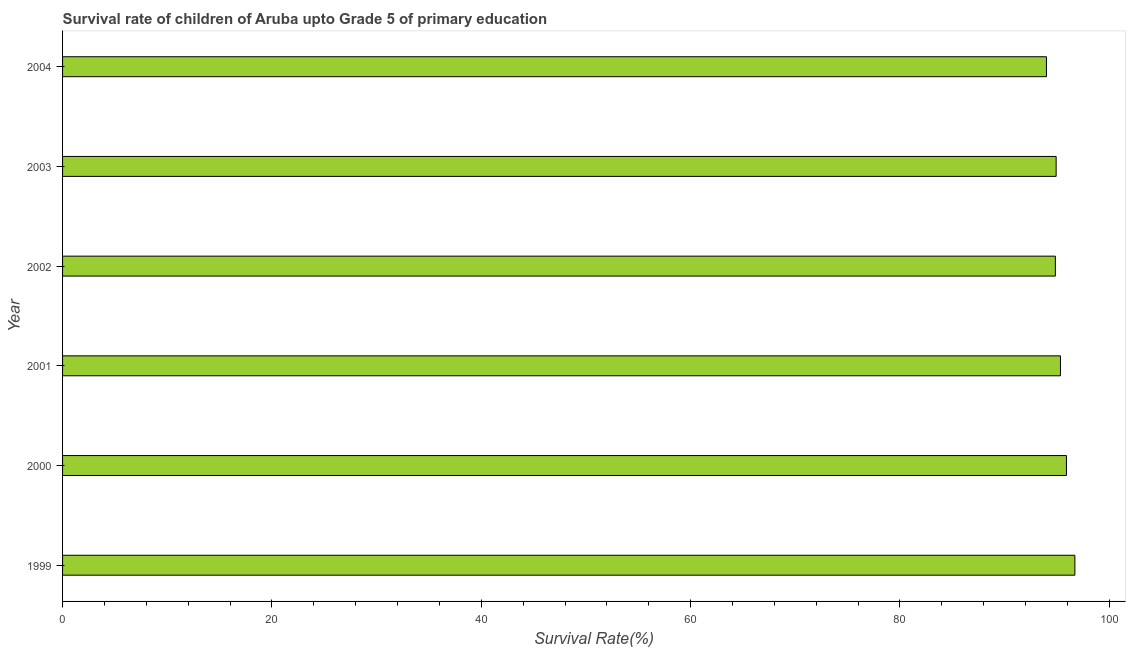Does the graph contain any zero values?
Keep it short and to the point. No. Does the graph contain grids?
Offer a terse response. No. What is the title of the graph?
Your answer should be compact. Survival rate of children of Aruba upto Grade 5 of primary education. What is the label or title of the X-axis?
Offer a terse response. Survival Rate(%). What is the survival rate in 1999?
Offer a terse response. 96.71. Across all years, what is the maximum survival rate?
Offer a terse response. 96.71. Across all years, what is the minimum survival rate?
Keep it short and to the point. 94. In which year was the survival rate maximum?
Your answer should be very brief. 1999. In which year was the survival rate minimum?
Make the answer very short. 2004. What is the sum of the survival rate?
Make the answer very short. 571.71. What is the difference between the survival rate in 1999 and 2002?
Your answer should be compact. 1.86. What is the average survival rate per year?
Keep it short and to the point. 95.28. What is the median survival rate?
Your answer should be very brief. 95.13. Is the difference between the survival rate in 2001 and 2002 greater than the difference between any two years?
Offer a very short reply. No. What is the difference between the highest and the second highest survival rate?
Offer a terse response. 0.81. What is the difference between the highest and the lowest survival rate?
Offer a terse response. 2.71. Are all the bars in the graph horizontal?
Your answer should be very brief. Yes. How many years are there in the graph?
Keep it short and to the point. 6. What is the Survival Rate(%) in 1999?
Offer a very short reply. 96.71. What is the Survival Rate(%) in 2000?
Make the answer very short. 95.91. What is the Survival Rate(%) in 2001?
Ensure brevity in your answer.  95.33. What is the Survival Rate(%) of 2002?
Give a very brief answer. 94.85. What is the Survival Rate(%) of 2003?
Your answer should be very brief. 94.92. What is the Survival Rate(%) of 2004?
Your response must be concise. 94. What is the difference between the Survival Rate(%) in 1999 and 2000?
Make the answer very short. 0.8. What is the difference between the Survival Rate(%) in 1999 and 2001?
Offer a terse response. 1.38. What is the difference between the Survival Rate(%) in 1999 and 2002?
Provide a short and direct response. 1.86. What is the difference between the Survival Rate(%) in 1999 and 2003?
Provide a short and direct response. 1.79. What is the difference between the Survival Rate(%) in 1999 and 2004?
Offer a very short reply. 2.71. What is the difference between the Survival Rate(%) in 2000 and 2001?
Keep it short and to the point. 0.57. What is the difference between the Survival Rate(%) in 2000 and 2002?
Ensure brevity in your answer.  1.06. What is the difference between the Survival Rate(%) in 2000 and 2003?
Make the answer very short. 0.99. What is the difference between the Survival Rate(%) in 2000 and 2004?
Make the answer very short. 1.91. What is the difference between the Survival Rate(%) in 2001 and 2002?
Offer a very short reply. 0.49. What is the difference between the Survival Rate(%) in 2001 and 2003?
Your response must be concise. 0.41. What is the difference between the Survival Rate(%) in 2001 and 2004?
Provide a succinct answer. 1.34. What is the difference between the Survival Rate(%) in 2002 and 2003?
Ensure brevity in your answer.  -0.07. What is the difference between the Survival Rate(%) in 2002 and 2004?
Give a very brief answer. 0.85. What is the difference between the Survival Rate(%) in 2003 and 2004?
Keep it short and to the point. 0.92. What is the ratio of the Survival Rate(%) in 1999 to that in 2001?
Give a very brief answer. 1.01. What is the ratio of the Survival Rate(%) in 1999 to that in 2004?
Ensure brevity in your answer.  1.03. What is the ratio of the Survival Rate(%) in 2000 to that in 2002?
Your response must be concise. 1.01. What is the ratio of the Survival Rate(%) in 2000 to that in 2003?
Keep it short and to the point. 1.01. What is the ratio of the Survival Rate(%) in 2001 to that in 2002?
Your answer should be very brief. 1. What is the ratio of the Survival Rate(%) in 2001 to that in 2003?
Offer a very short reply. 1. What is the ratio of the Survival Rate(%) in 2002 to that in 2003?
Offer a very short reply. 1. What is the ratio of the Survival Rate(%) in 2002 to that in 2004?
Your answer should be compact. 1.01. What is the ratio of the Survival Rate(%) in 2003 to that in 2004?
Offer a very short reply. 1.01. 